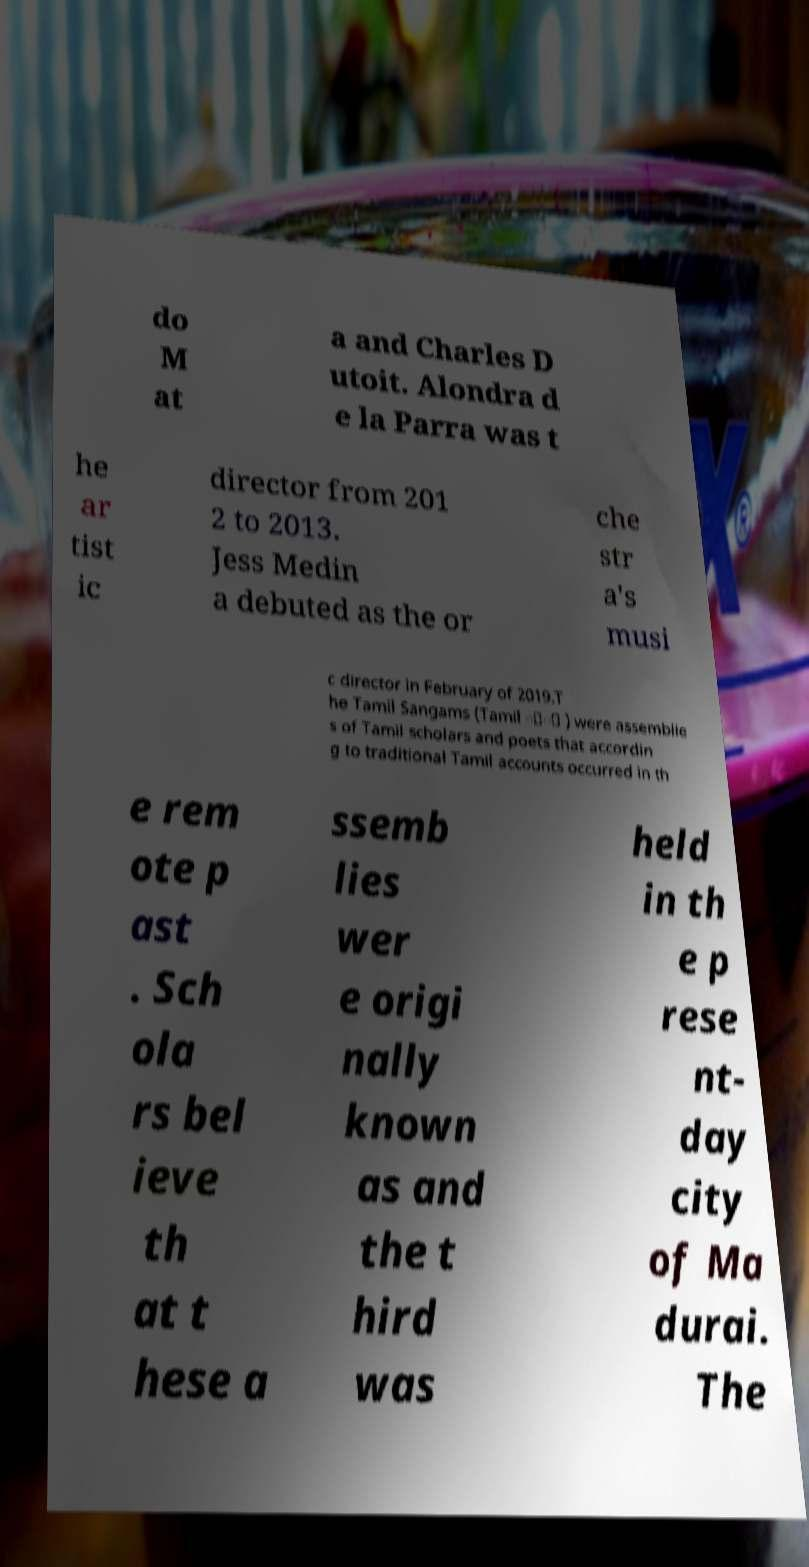Could you assist in decoding the text presented in this image and type it out clearly? do M at a and Charles D utoit. Alondra d e la Parra was t he ar tist ic director from 201 2 to 2013. Jess Medin a debuted as the or che str a's musi c director in February of 2019.T he Tamil Sangams (Tamil ்் ) were assemblie s of Tamil scholars and poets that accordin g to traditional Tamil accounts occurred in th e rem ote p ast . Sch ola rs bel ieve th at t hese a ssemb lies wer e origi nally known as and the t hird was held in th e p rese nt- day city of Ma durai. The 